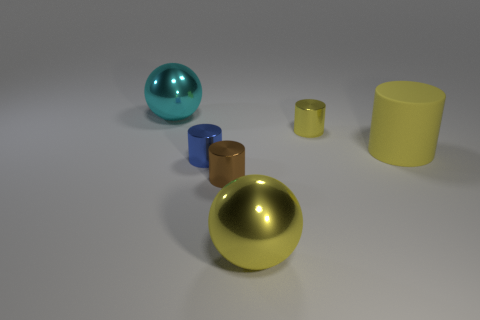Is there any other thing that has the same material as the big cylinder?
Provide a succinct answer. No. Is there a tiny object that is left of the shiny thing on the right side of the sphere in front of the big yellow rubber cylinder?
Your answer should be compact. Yes. What is the size of the other cylinder that is the same color as the large rubber cylinder?
Provide a short and direct response. Small. There is a small brown cylinder; are there any things to the left of it?
Keep it short and to the point. Yes. How many other things are there of the same shape as the large yellow rubber object?
Your response must be concise. 3. There is a shiny ball that is the same size as the cyan metal object; what color is it?
Ensure brevity in your answer.  Yellow. Are there fewer big cyan objects on the left side of the brown metallic thing than tiny cylinders that are in front of the tiny yellow metal cylinder?
Make the answer very short. Yes. What number of large things are on the right side of the big sphere that is behind the big yellow thing in front of the small blue metallic cylinder?
Ensure brevity in your answer.  2. There is a yellow metallic object that is the same shape as the blue shiny thing; what size is it?
Offer a very short reply. Small. Is the number of cyan shiny objects that are to the left of the yellow matte cylinder less than the number of small brown shiny things?
Your response must be concise. No. 